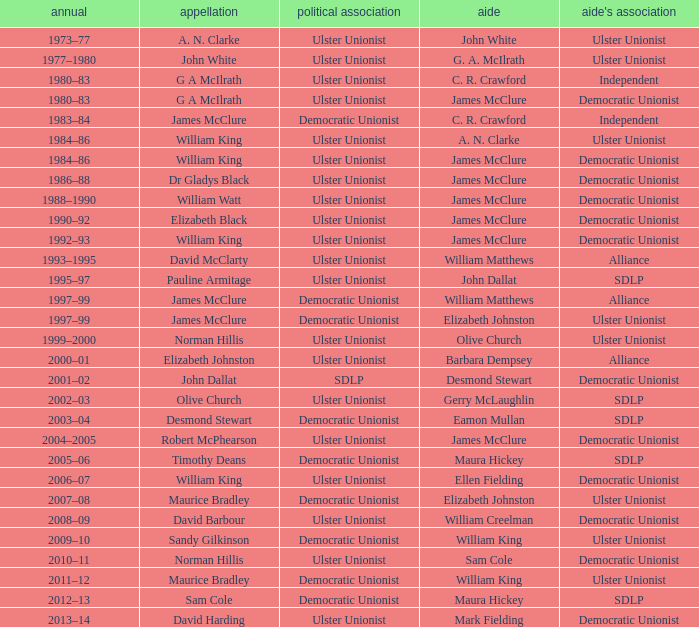What Year was james mcclure Deputy, and the Name is robert mcphearson? 2004–2005. 